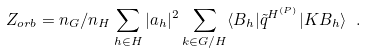Convert formula to latex. <formula><loc_0><loc_0><loc_500><loc_500>Z _ { o r b } = n _ { G } / n _ { H } \sum _ { h \in H } | a _ { h } | ^ { 2 } \sum _ { k \in G / H } \langle B _ { h } | \tilde { q } ^ { H ^ { ( P ) } } | K B _ { h } \rangle \ .</formula> 